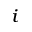<formula> <loc_0><loc_0><loc_500><loc_500>_ { i }</formula> 